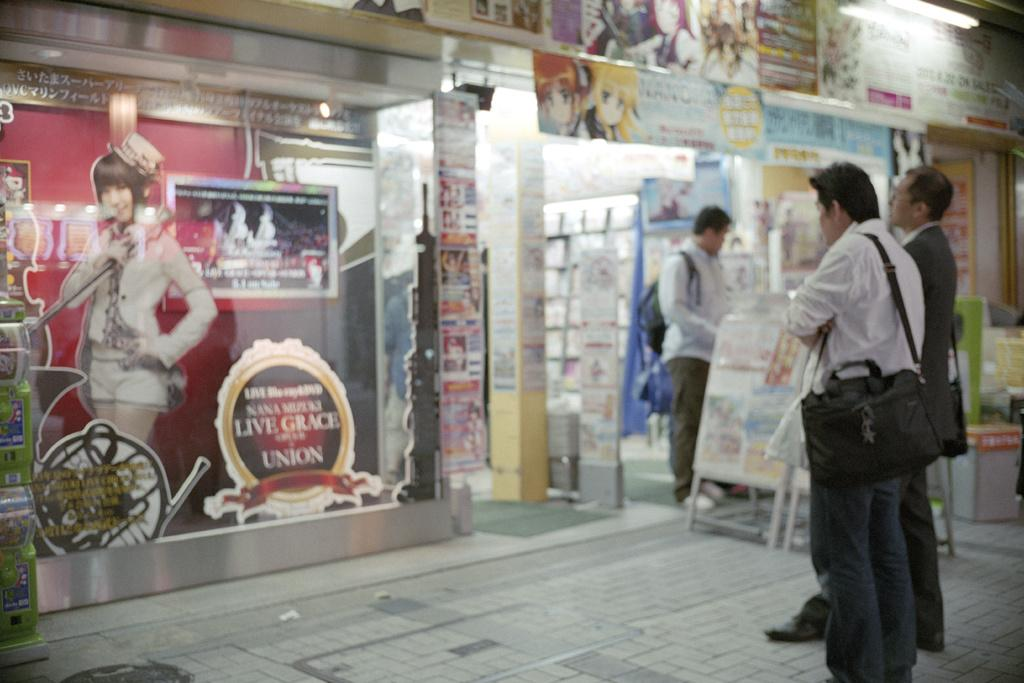<image>
Give a short and clear explanation of the subsequent image. Tourists are standing outside a store front that has a Live Grace sign. 